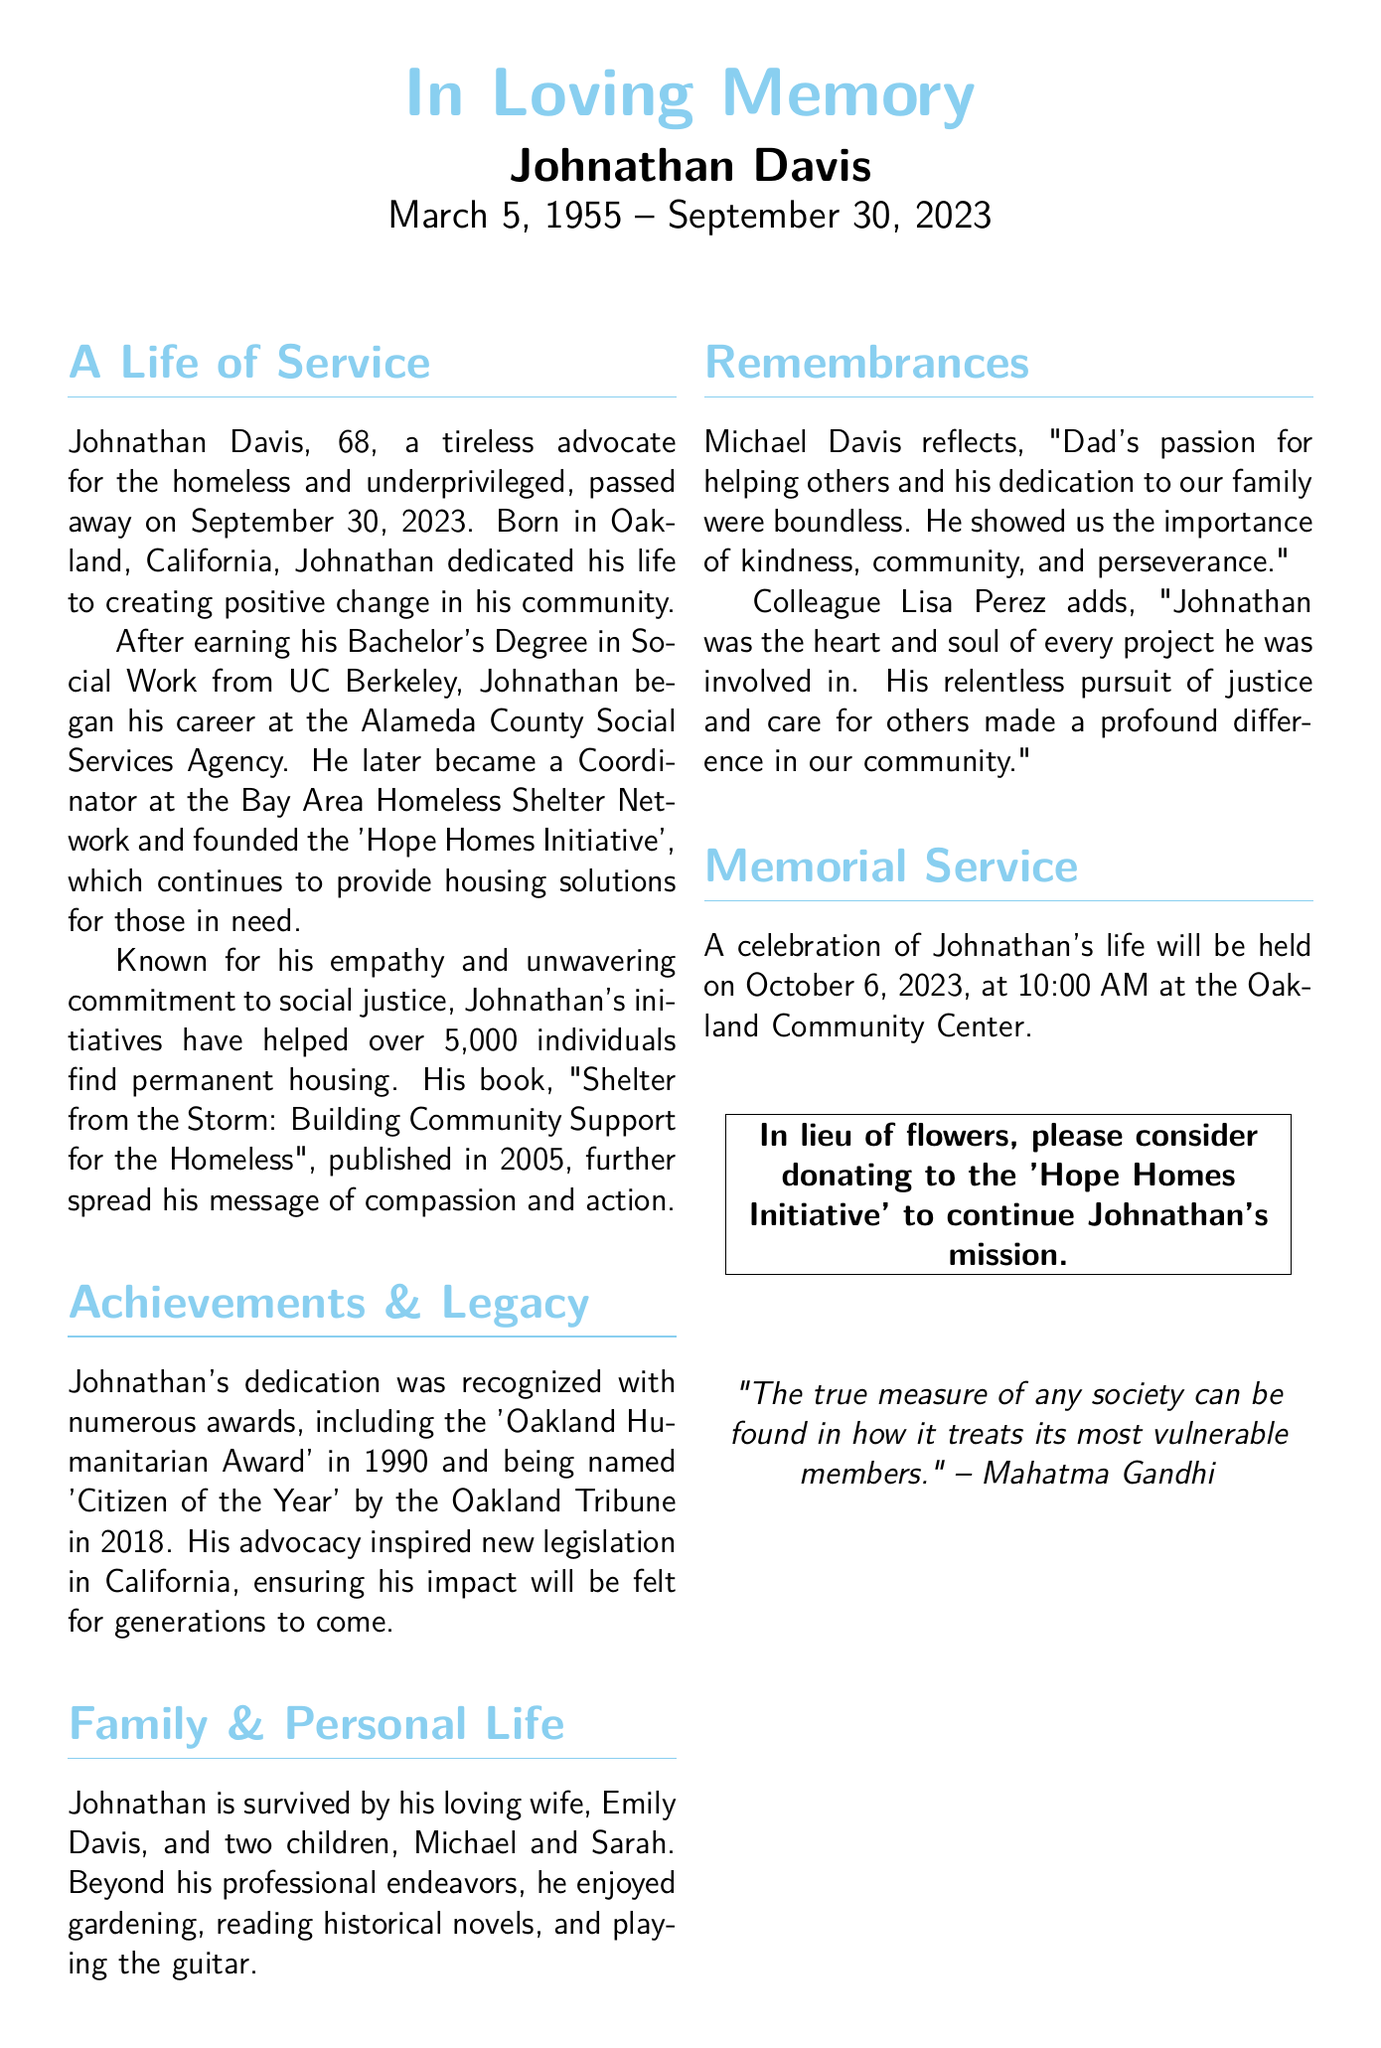What date did Johnathan Davis pass away? The document states that Johnathan Davis passed away on September 30, 2023.
Answer: September 30, 2023 What initiative did Johnathan Davis found? The text mentions that he founded the 'Hope Homes Initiative'.
Answer: Hope Homes Initiative How many individuals did Johnathan's initiatives help find housing? The document indicates that his initiatives helped over 5,000 individuals find permanent housing.
Answer: 5,000 What award did Johnathan receive in 1990? The document specifies that he received the 'Oakland Humanitarian Award' in 1990.
Answer: Oakland Humanitarian Award What is the name of Johnathan's book? The text references his book titled "Shelter from the Storm: Building Community Support for the Homeless."
Answer: Shelter from the Storm: Building Community Support for the Homeless What type of service will be held in Johnathan's honor? The document states that a celebration of his life will be held.
Answer: Celebration of life Who reflects on Johnathan's passion for helping others? Michael Davis, Johnathan's son, reflects on his passion for helping others.
Answer: Michael Davis What organization should people donate to in lieu of flowers? The obituary suggests donating to the 'Hope Homes Initiative' in lieu of flowers.
Answer: Hope Homes Initiative 